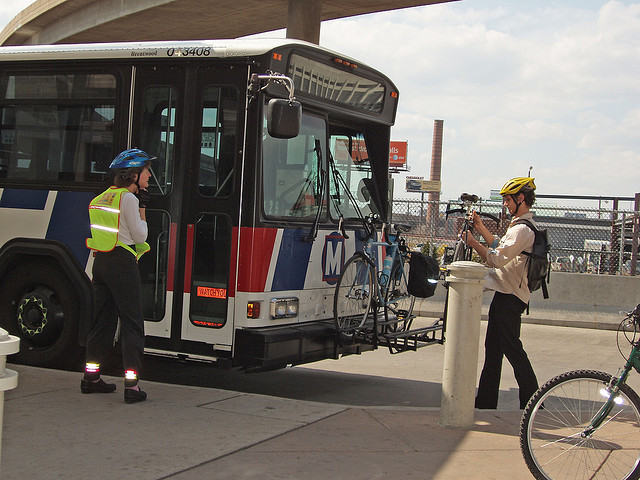Please transcribe the text information in this image. 3408 M 